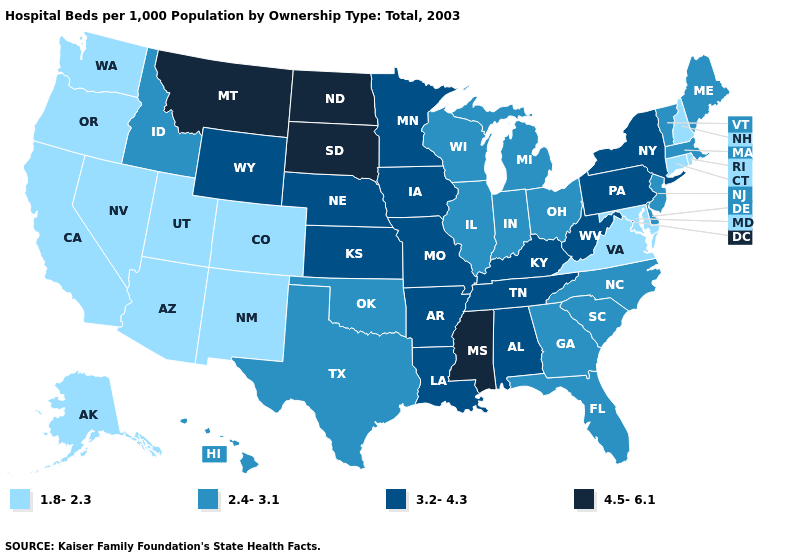What is the value of Rhode Island?
Answer briefly. 1.8-2.3. Does the first symbol in the legend represent the smallest category?
Write a very short answer. Yes. What is the value of Kansas?
Concise answer only. 3.2-4.3. Name the states that have a value in the range 4.5-6.1?
Answer briefly. Mississippi, Montana, North Dakota, South Dakota. Does Maryland have the lowest value in the South?
Give a very brief answer. Yes. Does South Dakota have the highest value in the MidWest?
Short answer required. Yes. Which states hav the highest value in the South?
Short answer required. Mississippi. What is the value of Washington?
Be succinct. 1.8-2.3. Name the states that have a value in the range 4.5-6.1?
Answer briefly. Mississippi, Montana, North Dakota, South Dakota. What is the value of Indiana?
Give a very brief answer. 2.4-3.1. Does Delaware have the same value as Missouri?
Be succinct. No. Name the states that have a value in the range 1.8-2.3?
Write a very short answer. Alaska, Arizona, California, Colorado, Connecticut, Maryland, Nevada, New Hampshire, New Mexico, Oregon, Rhode Island, Utah, Virginia, Washington. Name the states that have a value in the range 4.5-6.1?
Be succinct. Mississippi, Montana, North Dakota, South Dakota. What is the value of North Carolina?
Short answer required. 2.4-3.1. Which states have the lowest value in the South?
Concise answer only. Maryland, Virginia. 